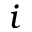<formula> <loc_0><loc_0><loc_500><loc_500>i</formula> 